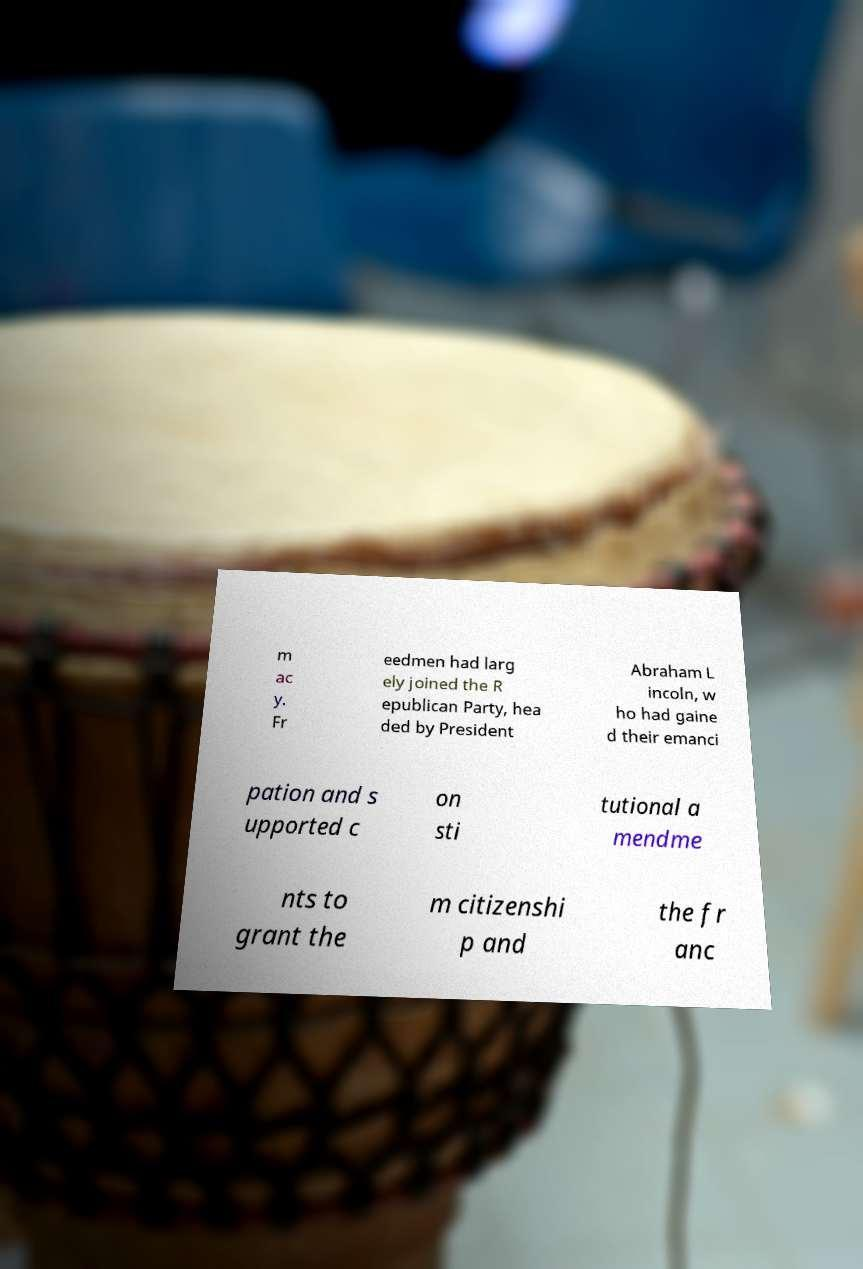I need the written content from this picture converted into text. Can you do that? m ac y. Fr eedmen had larg ely joined the R epublican Party, hea ded by President Abraham L incoln, w ho had gaine d their emanci pation and s upported c on sti tutional a mendme nts to grant the m citizenshi p and the fr anc 